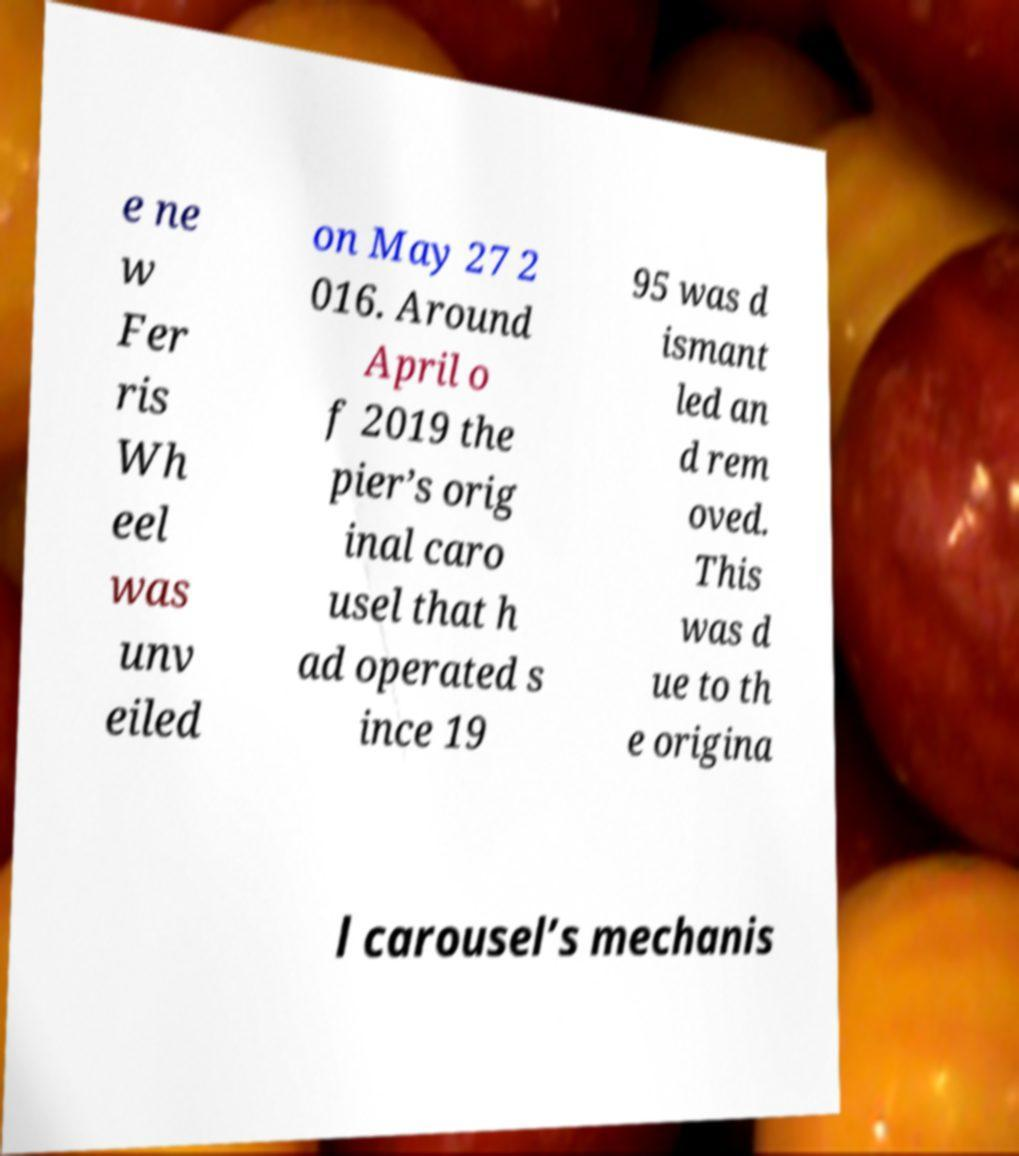Can you read and provide the text displayed in the image?This photo seems to have some interesting text. Can you extract and type it out for me? e ne w Fer ris Wh eel was unv eiled on May 27 2 016. Around April o f 2019 the pier’s orig inal caro usel that h ad operated s ince 19 95 was d ismant led an d rem oved. This was d ue to th e origina l carousel’s mechanis 